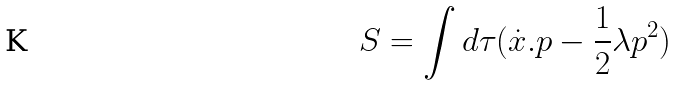<formula> <loc_0><loc_0><loc_500><loc_500>S = \int d \tau ( \dot { x } . p - \frac { 1 } { 2 } \lambda p ^ { 2 } )</formula> 